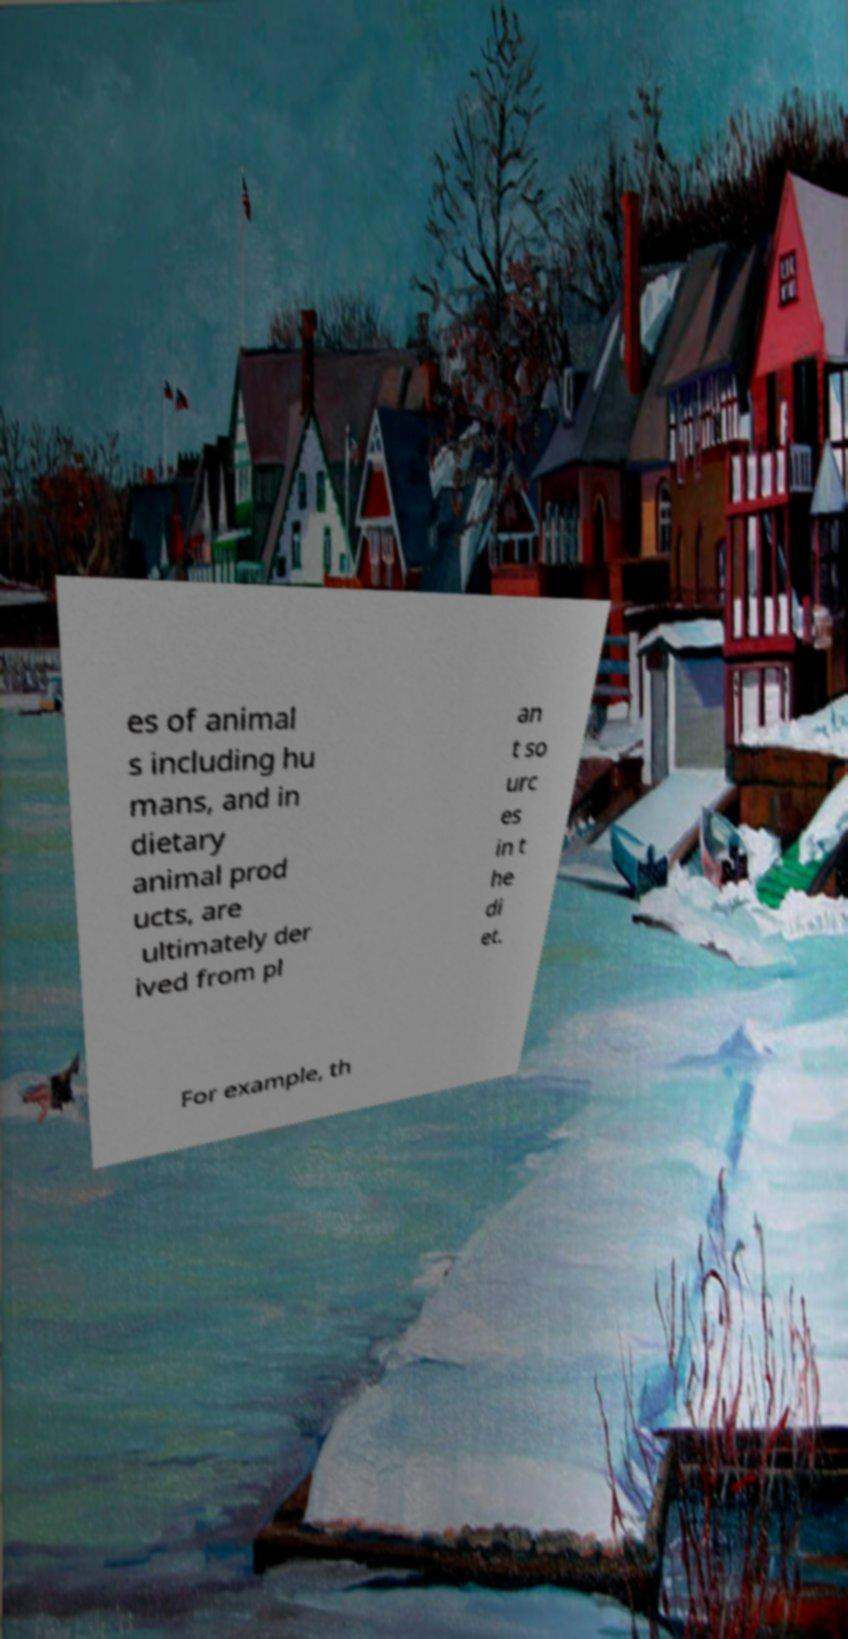Can you accurately transcribe the text from the provided image for me? es of animal s including hu mans, and in dietary animal prod ucts, are ultimately der ived from pl an t so urc es in t he di et. For example, th 